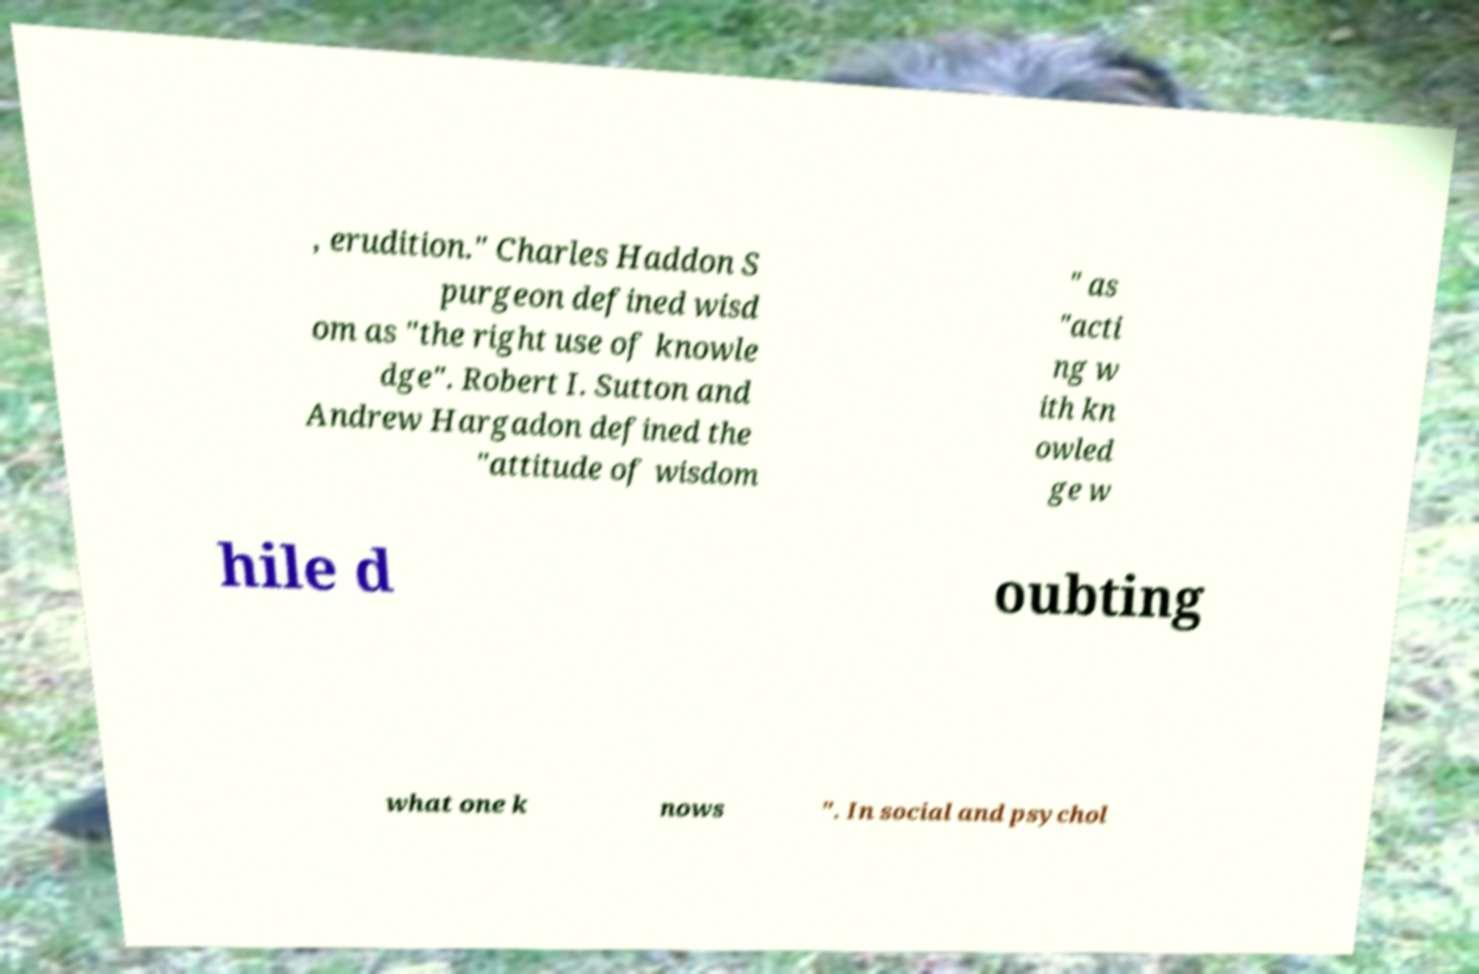Could you extract and type out the text from this image? , erudition." Charles Haddon S purgeon defined wisd om as "the right use of knowle dge". Robert I. Sutton and Andrew Hargadon defined the "attitude of wisdom " as "acti ng w ith kn owled ge w hile d oubting what one k nows ". In social and psychol 